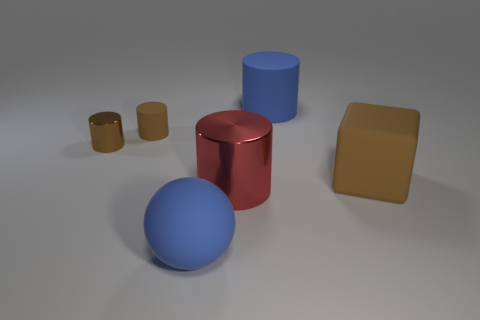How many purple things are either rubber cubes or small cylinders?
Your answer should be very brief. 0. Are there any blue cylinders that have the same size as the red cylinder?
Keep it short and to the point. Yes. The blue object that is to the left of the blue matte thing on the right side of the blue rubber thing that is left of the large matte cylinder is made of what material?
Offer a terse response. Rubber. Are there the same number of big rubber objects that are in front of the blue cylinder and large red metallic things?
Keep it short and to the point. No. Is the material of the blue object that is in front of the big brown rubber object the same as the large red object left of the block?
Your answer should be compact. No. How many objects are red metallic cylinders or big blue matte things that are in front of the big rubber cylinder?
Your response must be concise. 2. Is there another brown object that has the same shape as the small metal thing?
Give a very brief answer. Yes. What is the size of the metal cylinder in front of the brown rubber object to the right of the big matte cylinder left of the large cube?
Offer a very short reply. Large. Are there an equal number of small things that are to the left of the red metal cylinder and matte objects that are behind the big blue cylinder?
Your response must be concise. No. There is a sphere that is made of the same material as the blue cylinder; what is its size?
Offer a very short reply. Large. 